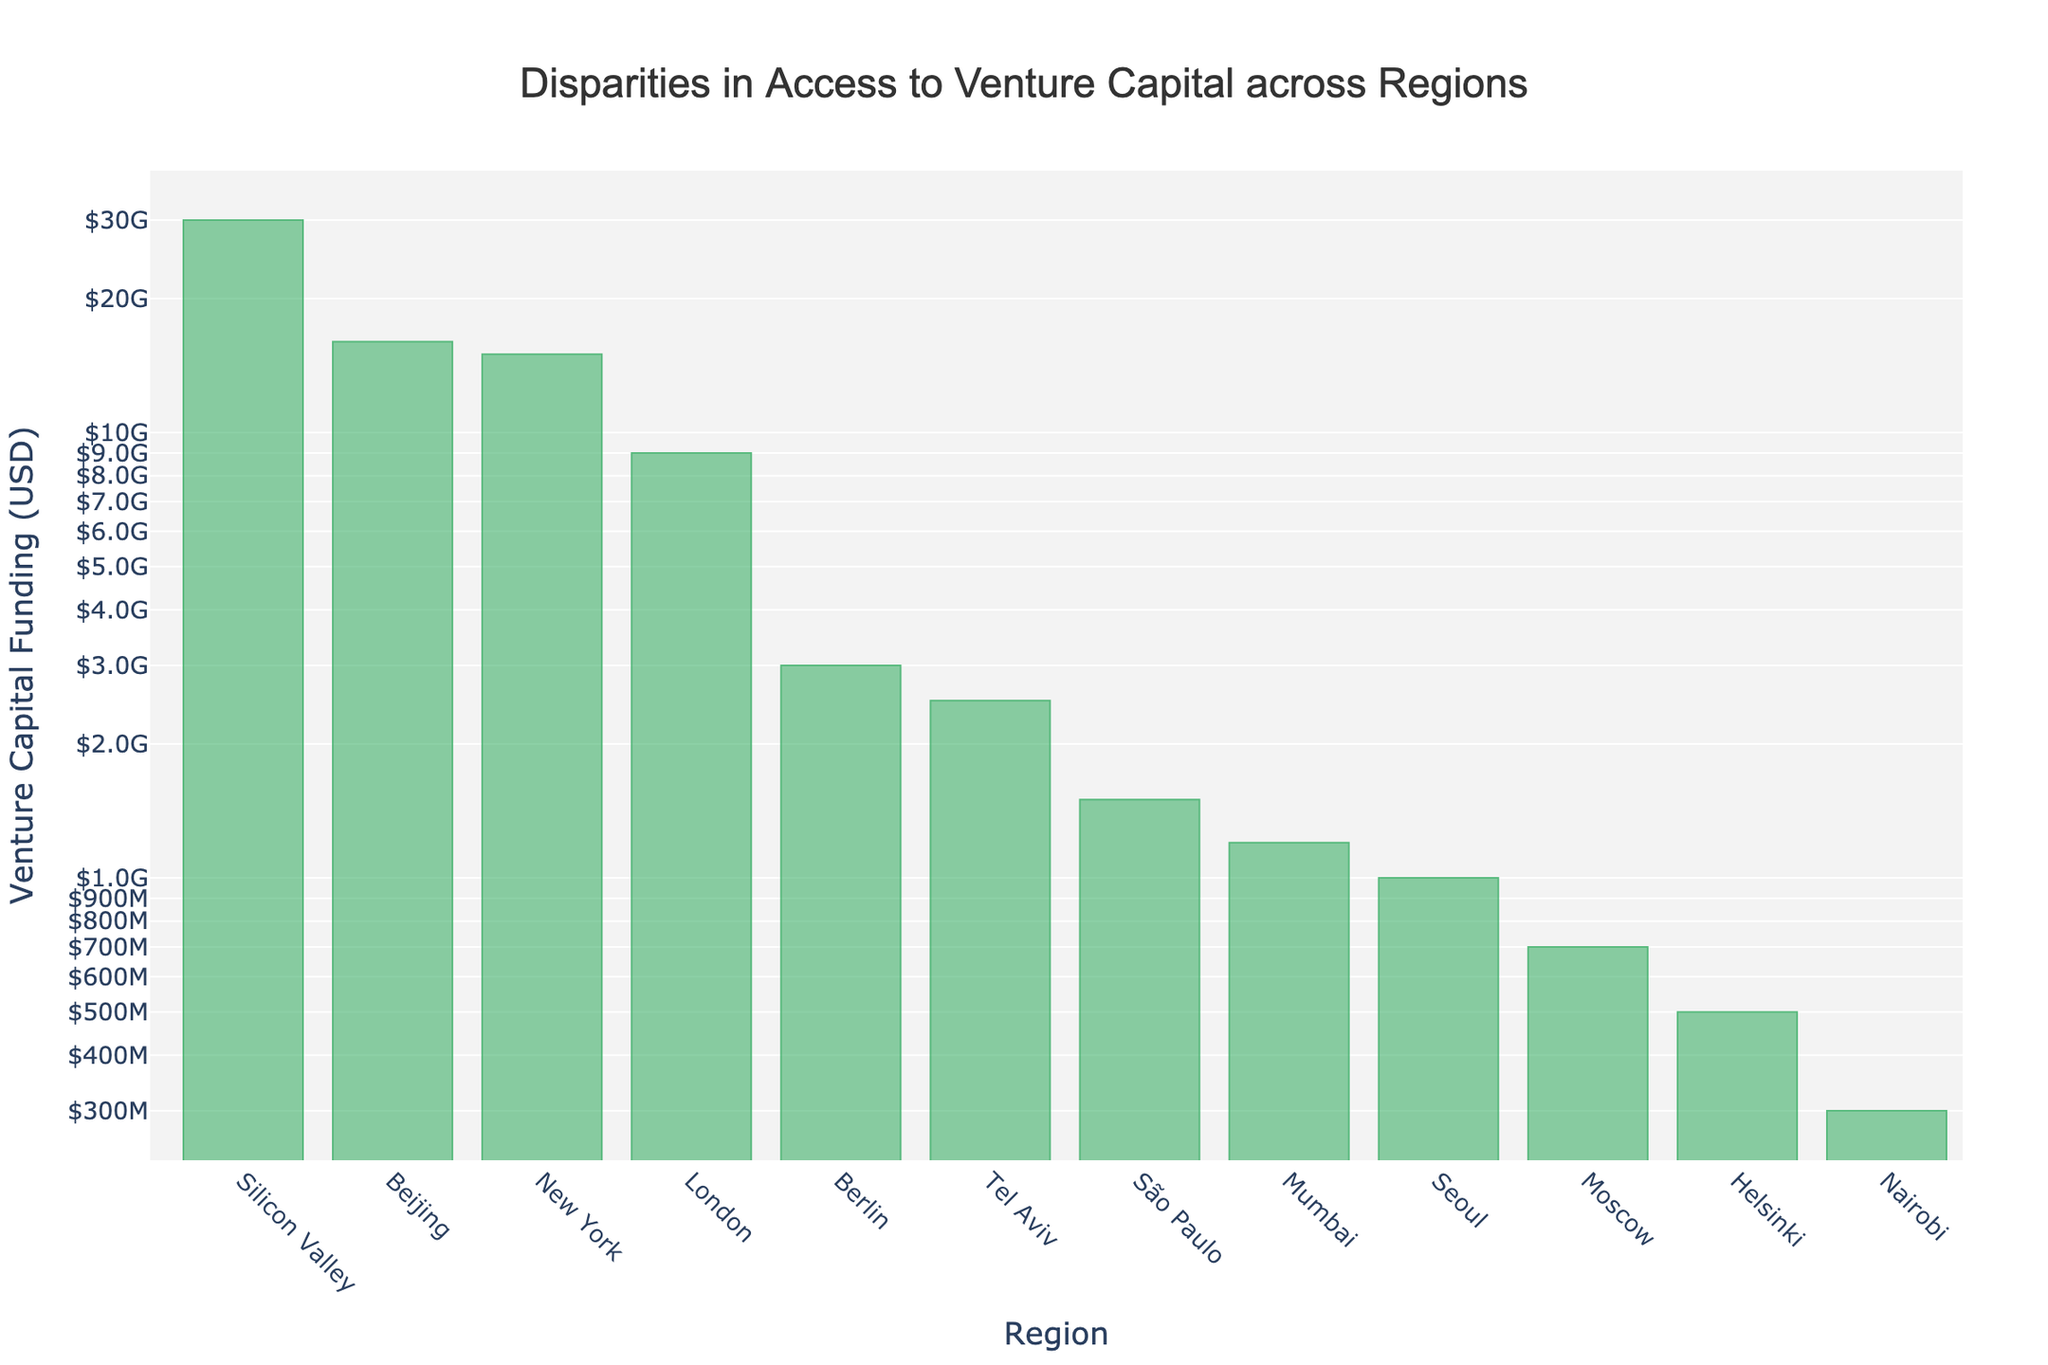What is the title of the plot? The title is written at the top center of the plot. It reads "Disparities in Access to Venture Capital across Regions".
Answer: Disparities in Access to Venture Capital across Regions Which region has the highest venture capital funding? By examining the heights of the bars on the plot, Silicon Valley has the highest bar, indicating the highest venture capital funding.
Answer: Silicon Valley Which two regions have venture capital funding figures closest to each other? By comparing the bar heights and the annotations, Moscow ($700 million) and Helsinki ($500 million) have venture capital funding figures closest to each other.
Answer: Moscow and Helsinki What is the funding disparity between Silicon Valley and New York? Silicon Valley has $30 billion, and New York has $15 billion. Subtracting New York's funding from Silicon Valley’s funding: $30,000,000,000 - $15,000,000,000.
Answer: $15 billion Which region has the lowest venture capital funding? Nairobi has the shortest bar on the plot, indicating the lowest venture capital funding of $300 million.
Answer: Nairobi How does the funding in London compare to Tel Aviv? London's funding is $9 billion, and Tel Aviv’s funding is $2.5 billion. London has $6.5 billion more funding than Tel Aviv.
Answer: $6.5 billion more What is the total venture capital funding for Berlin, Seoul, Tel Aviv, and São Paulo combined? Summing the venture capital funding for these four regions: Berlin ($3 billion) + Seoul ($1 billion) + Tel Aviv ($2.5 billion) + São Paulo ($1.5 billion) = $8 billion.
Answer: $8 billion What is the threshold of venture capital funding for regions with over $10 billion? Only Silicon Valley, New York, and Beijing have funding over $10 billion. This threshold is $10 billion.
Answer: $10 billion Besides Silicon Valley, which other region has a venture capital funding amount that is a multiple of $3 billion? Beijing has $16 billion, which is a multiple of $3 billion.
Answer: Beijing What is the venture capital funding difference between New York and Beijing? New York has $15 billion, and Beijing has $16 billion. The difference is $16,000,000,000 - $15,000,000,000.
Answer: $1 billion 